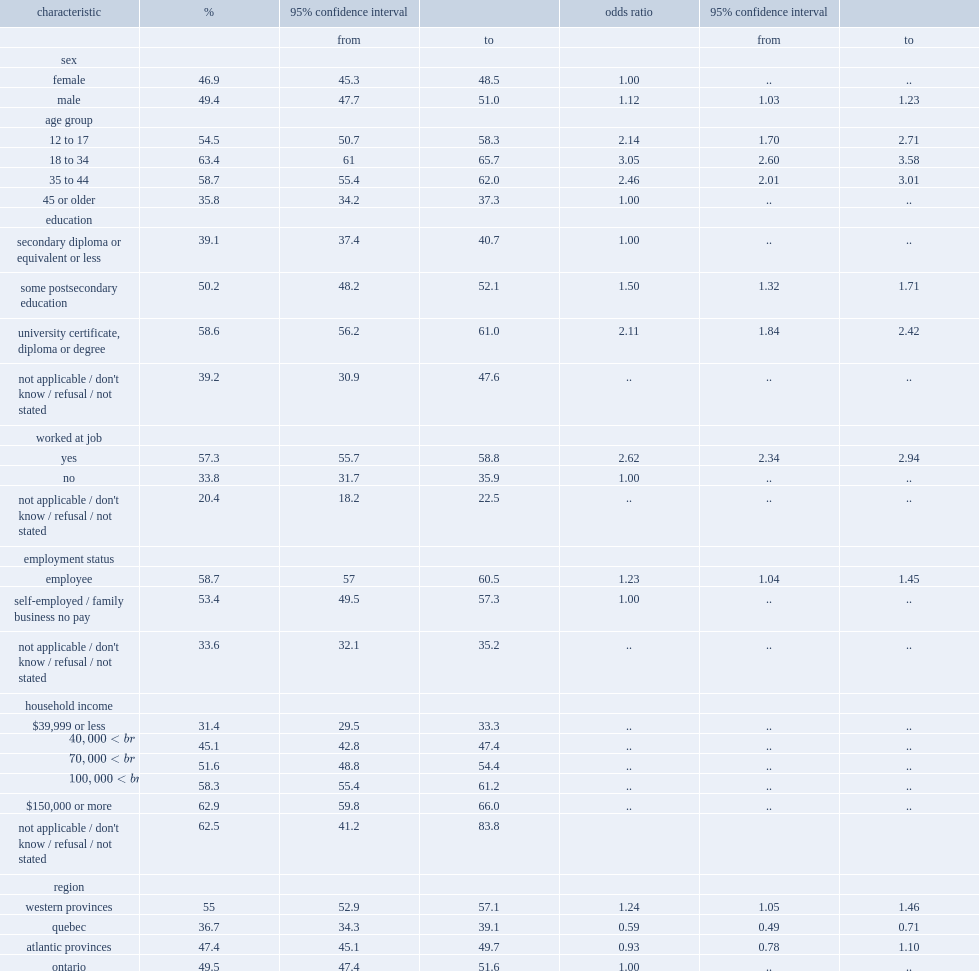In 2014, what was the proportion of canadians aged 12 or older reported using or being exposed to beams from a laser device in the previous 12 months? 48.15. How many times were the odds of canadian males using or being exposed to a laser device higher than for females? 1.12. Between 12 to 17 age group and 45 or older age group, which had a higher prevalence of exposure? 12 to 17. Between 18 to 34 age group and 45 or older age group, which had a higher prevalence of exposure? 18 to 34. Between 35 to 44 age group and 45 or older age group, which had a higher prevalence of exposure? 35 to 44. What was the prevalence of laser use or exposure among canadians with a "university certificate, diploma or degree". 58.6. What was the prevalence of laser use or exposure among canadians with a "some postsecondary education (certificate or diploma including trades)". 50.2. What was the prevalence of laser use or exposure among canadians with a "secondary diploma or equivalent or less". 39.1. Did canadians self-employed have a lower prevalence of exposure or usage of laser products or did those who were employed by a company or organization? Self-employed / family business no pay. Was the prevalence of canadians who were exposed to or used laser products in ontario higher or was that in the western provinces? Western provinces. Was the prevalence of canadians who were exposed to or used laser products in ontario higher or was that in quebec? Quebec. 